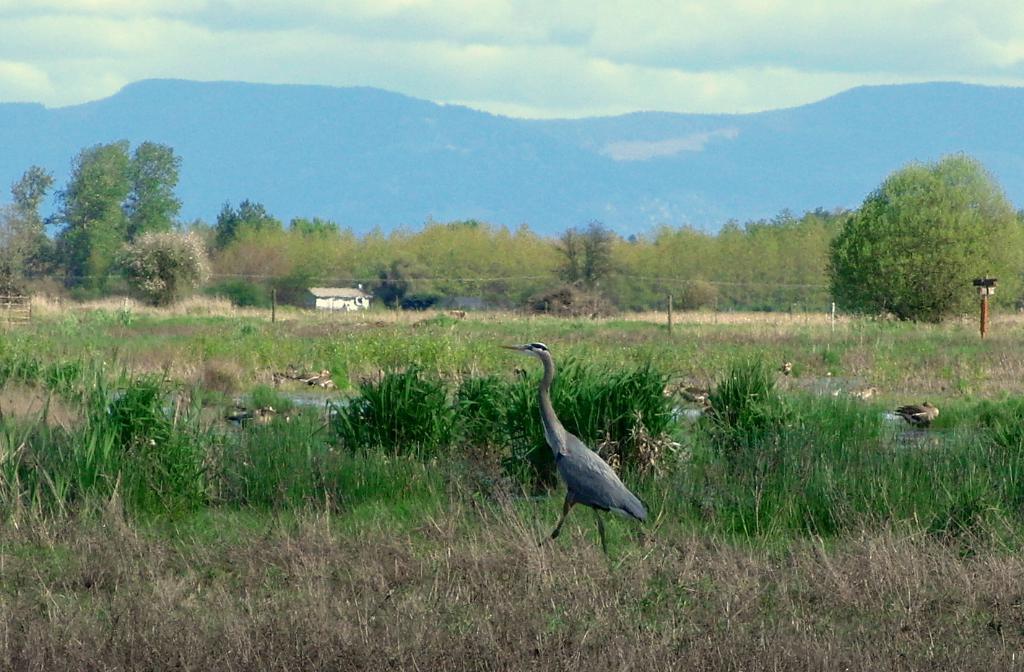Please provide a concise description of this image. In this picture there is great blue heron in the center of the image and there are other ducks in the image, there is greenery around the area of the image and there is a house in the background area of the mage. 